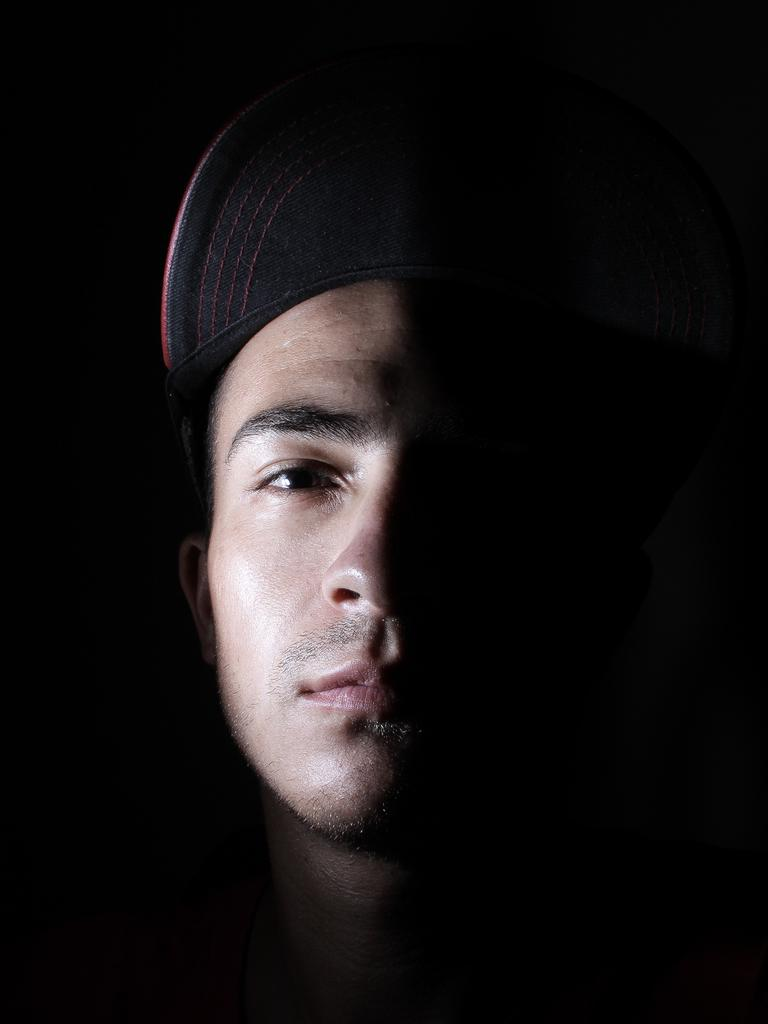What is the main subject of the image? There is a person in the image. What is the person wearing on their head? The person is wearing a cap. Can you describe the background of the image? The background of the image is dark. What is the sister's name in the image? There is no mention of a sister or any other person in the image, so we cannot determine the name of a sister. What type of quiver is the person holding in the image? There is no quiver present in the image. 